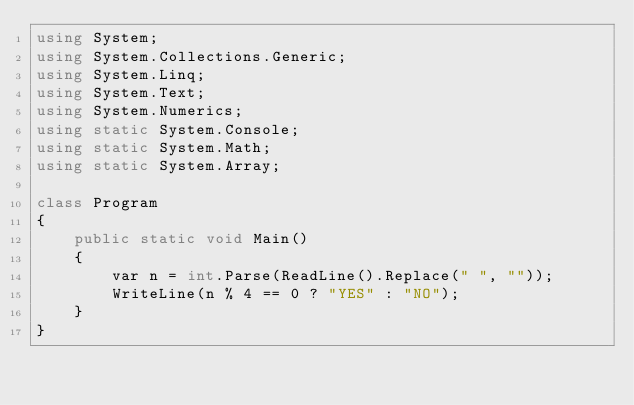Convert code to text. <code><loc_0><loc_0><loc_500><loc_500><_C#_>using System;
using System.Collections.Generic;
using System.Linq;
using System.Text;
using System.Numerics;
using static System.Console;
using static System.Math;
using static System.Array;

class Program
{
    public static void Main()
    {
        var n = int.Parse(ReadLine().Replace(" ", ""));
        WriteLine(n % 4 == 0 ? "YES" : "NO");
    }
}

</code> 